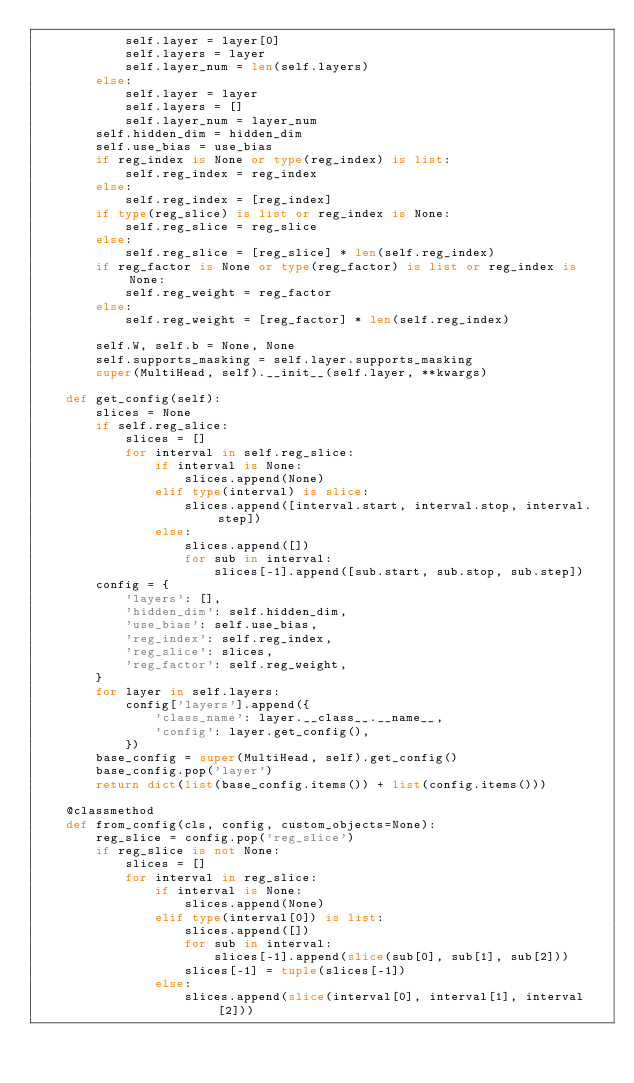<code> <loc_0><loc_0><loc_500><loc_500><_Python_>            self.layer = layer[0]
            self.layers = layer
            self.layer_num = len(self.layers)
        else:
            self.layer = layer
            self.layers = []
            self.layer_num = layer_num
        self.hidden_dim = hidden_dim
        self.use_bias = use_bias
        if reg_index is None or type(reg_index) is list:
            self.reg_index = reg_index
        else:
            self.reg_index = [reg_index]
        if type(reg_slice) is list or reg_index is None:
            self.reg_slice = reg_slice
        else:
            self.reg_slice = [reg_slice] * len(self.reg_index)
        if reg_factor is None or type(reg_factor) is list or reg_index is None:
            self.reg_weight = reg_factor
        else:
            self.reg_weight = [reg_factor] * len(self.reg_index)

        self.W, self.b = None, None
        self.supports_masking = self.layer.supports_masking
        super(MultiHead, self).__init__(self.layer, **kwargs)

    def get_config(self):
        slices = None
        if self.reg_slice:
            slices = []
            for interval in self.reg_slice:
                if interval is None:
                    slices.append(None)
                elif type(interval) is slice:
                    slices.append([interval.start, interval.stop, interval.step])
                else:
                    slices.append([])
                    for sub in interval:
                        slices[-1].append([sub.start, sub.stop, sub.step])
        config = {
            'layers': [],
            'hidden_dim': self.hidden_dim,
            'use_bias': self.use_bias,
            'reg_index': self.reg_index,
            'reg_slice': slices,
            'reg_factor': self.reg_weight,
        }
        for layer in self.layers:
            config['layers'].append({
                'class_name': layer.__class__.__name__,
                'config': layer.get_config(),
            })
        base_config = super(MultiHead, self).get_config()
        base_config.pop('layer')
        return dict(list(base_config.items()) + list(config.items()))

    @classmethod
    def from_config(cls, config, custom_objects=None):
        reg_slice = config.pop('reg_slice')
        if reg_slice is not None:
            slices = []
            for interval in reg_slice:
                if interval is None:
                    slices.append(None)
                elif type(interval[0]) is list:
                    slices.append([])
                    for sub in interval:
                        slices[-1].append(slice(sub[0], sub[1], sub[2]))
                    slices[-1] = tuple(slices[-1])
                else:
                    slices.append(slice(interval[0], interval[1], interval[2]))</code> 